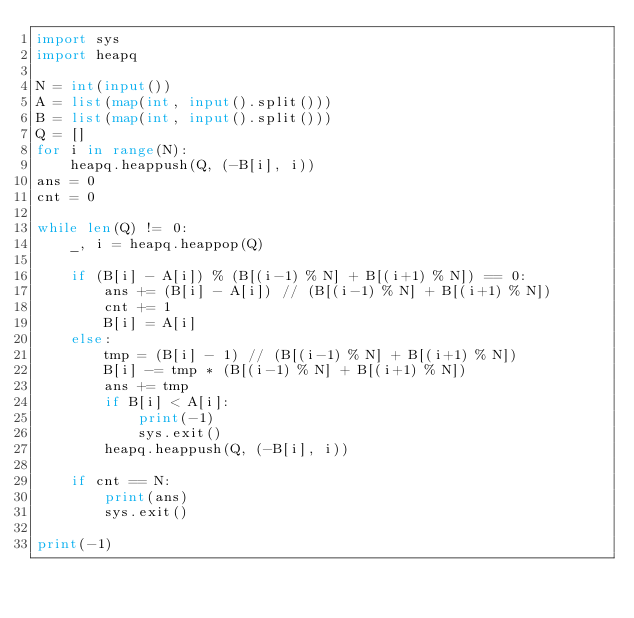<code> <loc_0><loc_0><loc_500><loc_500><_Python_>import sys
import heapq

N = int(input())
A = list(map(int, input().split()))
B = list(map(int, input().split()))
Q = []
for i in range(N):
    heapq.heappush(Q, (-B[i], i))
ans = 0
cnt = 0

while len(Q) != 0:
    _, i = heapq.heappop(Q)

    if (B[i] - A[i]) % (B[(i-1) % N] + B[(i+1) % N]) == 0:
        ans += (B[i] - A[i]) // (B[(i-1) % N] + B[(i+1) % N])
        cnt += 1
        B[i] = A[i]
    else:
        tmp = (B[i] - 1) // (B[(i-1) % N] + B[(i+1) % N])
        B[i] -= tmp * (B[(i-1) % N] + B[(i+1) % N])
        ans += tmp
        if B[i] < A[i]:
            print(-1)
            sys.exit()
        heapq.heappush(Q, (-B[i], i))
    
    if cnt == N:
        print(ans)
        sys.exit()

print(-1)</code> 